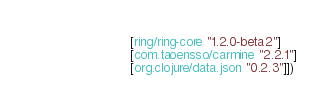Convert code to text. <code><loc_0><loc_0><loc_500><loc_500><_Clojure_>                 [ring/ring-core "1.2.0-beta2"]
                 [com.taoensso/carmine "2.2.1"]
                 [org.clojure/data.json "0.2.3"]])</code> 